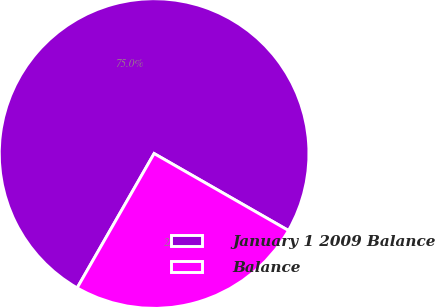Convert chart to OTSL. <chart><loc_0><loc_0><loc_500><loc_500><pie_chart><fcel>January 1 2009 Balance<fcel>Balance<nl><fcel>75.0%<fcel>25.0%<nl></chart> 